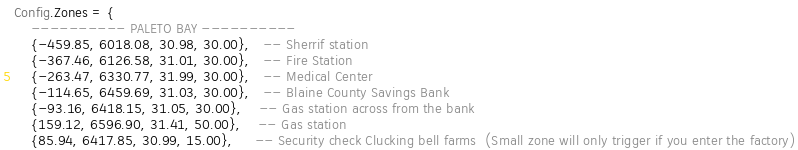<code> <loc_0><loc_0><loc_500><loc_500><_Lua_>Config.Zones = {
    ---------- PALETO BAY ----------
    {-459.85, 6018.08, 30.98, 30.00},   -- Sherrif station
    {-367.46, 6126.58, 31.01, 30.00},   -- Fire Station
    {-263.47, 6330.77, 31.99, 30.00},   -- Medical Center
    {-114.65, 6459.69, 31.03, 30.00},   -- Blaine County Savings Bank
    {-93.16, 6418.15, 31.05, 30.00},    -- Gas station across from the bank
    {159.12, 6596.90, 31.41, 50.00},    -- Gas station
    {85.94, 6417.85, 30.99, 15.00},     -- Security check Clucking bell farms  (Small zone will only trigger if you enter the factory)</code> 